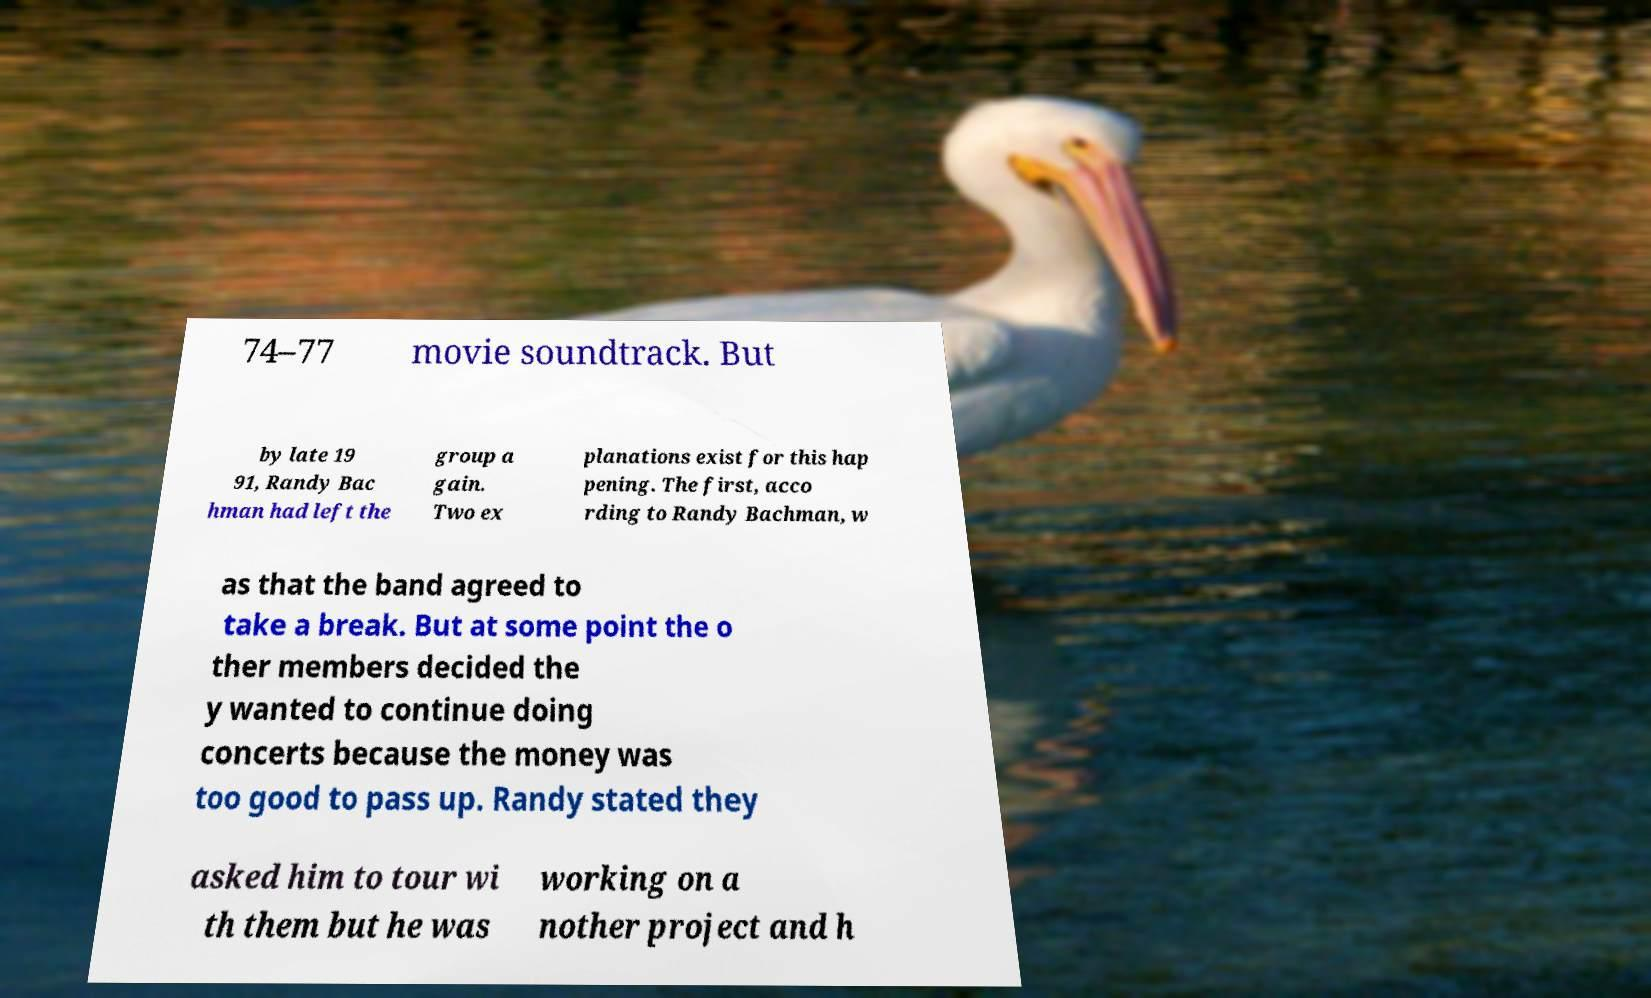I need the written content from this picture converted into text. Can you do that? 74–77 movie soundtrack. But by late 19 91, Randy Bac hman had left the group a gain. Two ex planations exist for this hap pening. The first, acco rding to Randy Bachman, w as that the band agreed to take a break. But at some point the o ther members decided the y wanted to continue doing concerts because the money was too good to pass up. Randy stated they asked him to tour wi th them but he was working on a nother project and h 